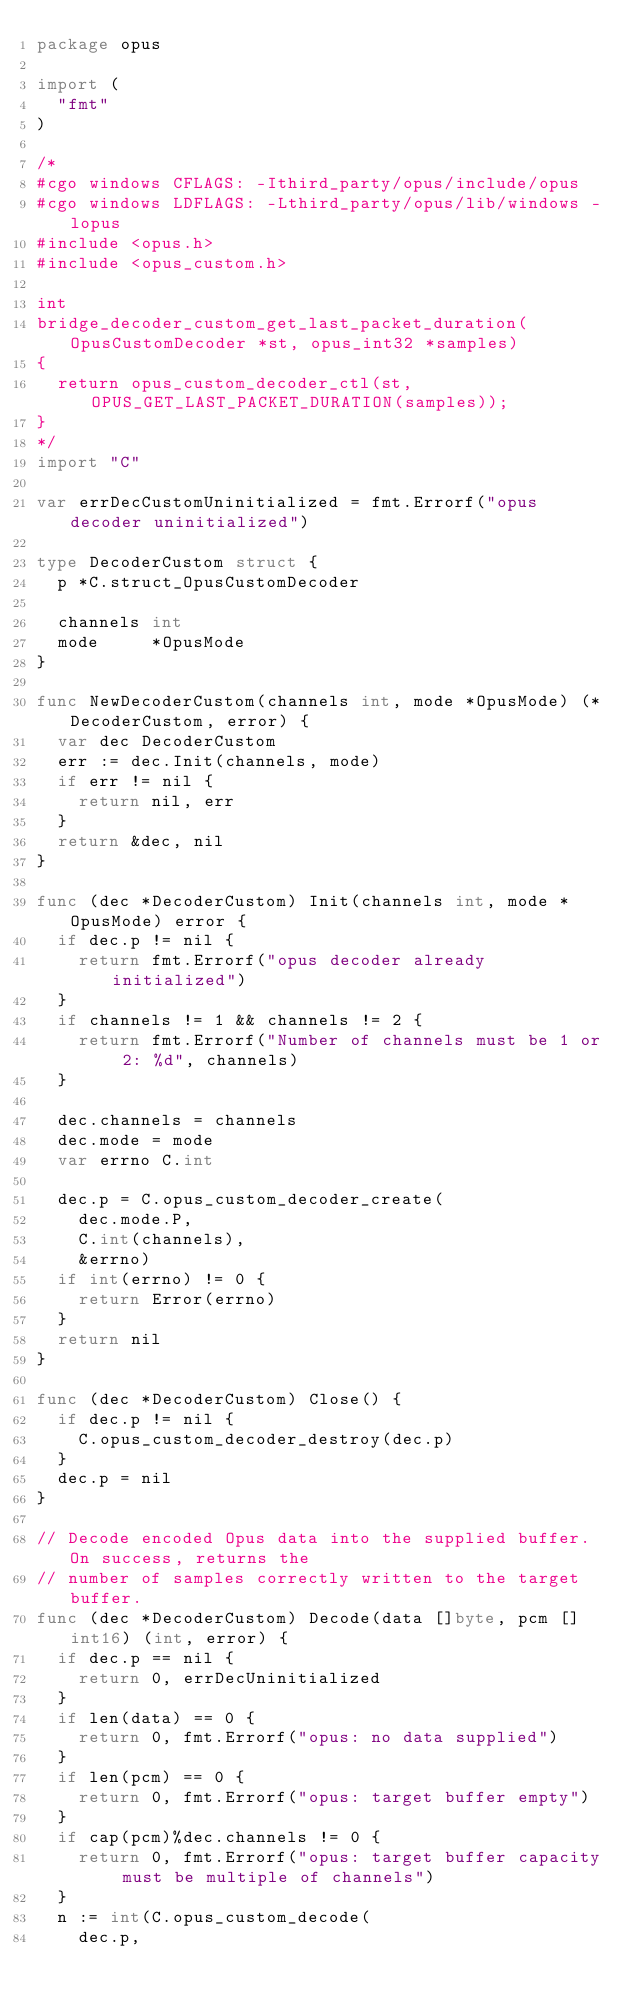Convert code to text. <code><loc_0><loc_0><loc_500><loc_500><_Go_>package opus

import (
	"fmt"
)

/*
#cgo windows CFLAGS: -Ithird_party/opus/include/opus
#cgo windows LDFLAGS: -Lthird_party/opus/lib/windows -lopus
#include <opus.h>
#include <opus_custom.h>

int
bridge_decoder_custom_get_last_packet_duration(OpusCustomDecoder *st, opus_int32 *samples)
{
	return opus_custom_decoder_ctl(st, OPUS_GET_LAST_PACKET_DURATION(samples));
}
*/
import "C"

var errDecCustomUninitialized = fmt.Errorf("opus decoder uninitialized")

type DecoderCustom struct {
	p *C.struct_OpusCustomDecoder

	channels int
	mode     *OpusMode
}

func NewDecoderCustom(channels int, mode *OpusMode) (*DecoderCustom, error) {
	var dec DecoderCustom
	err := dec.Init(channels, mode)
	if err != nil {
		return nil, err
	}
	return &dec, nil
}

func (dec *DecoderCustom) Init(channels int, mode *OpusMode) error {
	if dec.p != nil {
		return fmt.Errorf("opus decoder already initialized")
	}
	if channels != 1 && channels != 2 {
		return fmt.Errorf("Number of channels must be 1 or 2: %d", channels)
	}

	dec.channels = channels
	dec.mode = mode
	var errno C.int

	dec.p = C.opus_custom_decoder_create(
		dec.mode.P,
		C.int(channels),
		&errno)
	if int(errno) != 0 {
		return Error(errno)
	}
	return nil
}

func (dec *DecoderCustom) Close() {
	if dec.p != nil {
		C.opus_custom_decoder_destroy(dec.p)
	}
	dec.p = nil
}

// Decode encoded Opus data into the supplied buffer. On success, returns the
// number of samples correctly written to the target buffer.
func (dec *DecoderCustom) Decode(data []byte, pcm []int16) (int, error) {
	if dec.p == nil {
		return 0, errDecUninitialized
	}
	if len(data) == 0 {
		return 0, fmt.Errorf("opus: no data supplied")
	}
	if len(pcm) == 0 {
		return 0, fmt.Errorf("opus: target buffer empty")
	}
	if cap(pcm)%dec.channels != 0 {
		return 0, fmt.Errorf("opus: target buffer capacity must be multiple of channels")
	}
	n := int(C.opus_custom_decode(
		dec.p,</code> 